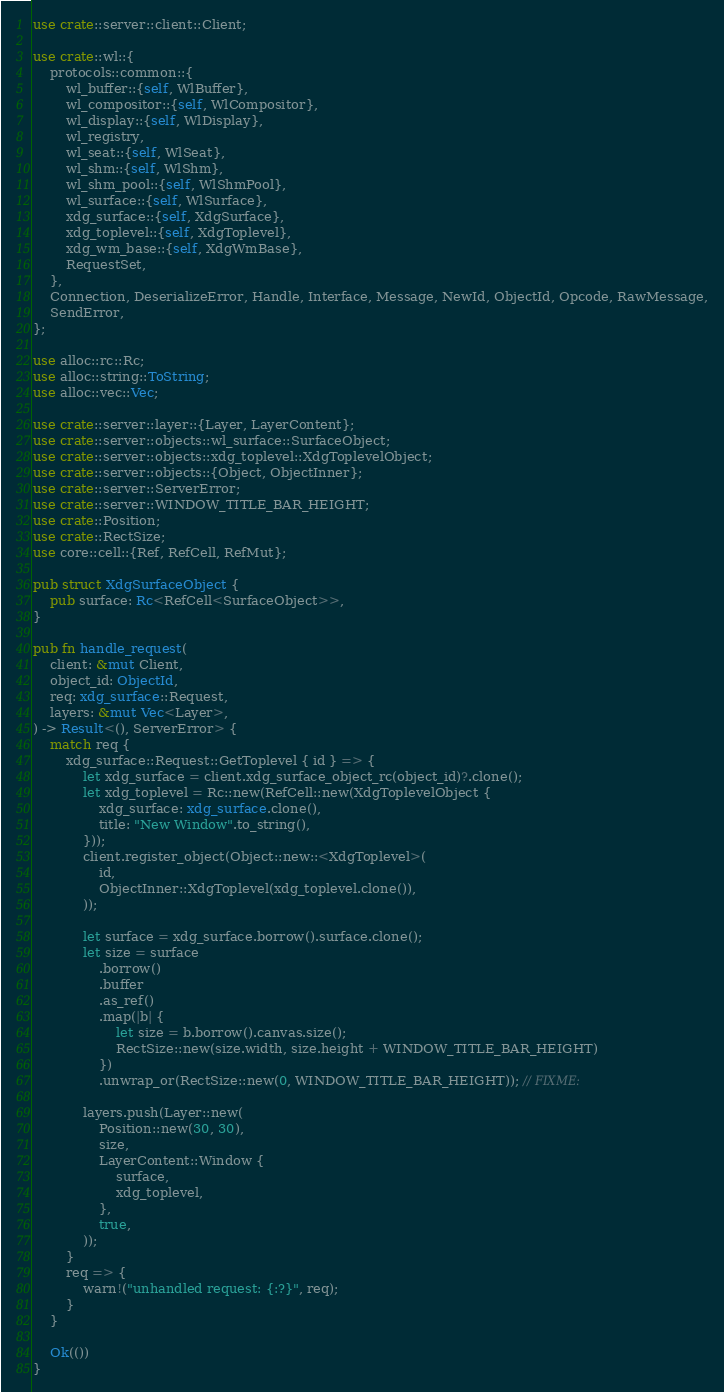<code> <loc_0><loc_0><loc_500><loc_500><_Rust_>use crate::server::client::Client;

use crate::wl::{
    protocols::common::{
        wl_buffer::{self, WlBuffer},
        wl_compositor::{self, WlCompositor},
        wl_display::{self, WlDisplay},
        wl_registry,
        wl_seat::{self, WlSeat},
        wl_shm::{self, WlShm},
        wl_shm_pool::{self, WlShmPool},
        wl_surface::{self, WlSurface},
        xdg_surface::{self, XdgSurface},
        xdg_toplevel::{self, XdgToplevel},
        xdg_wm_base::{self, XdgWmBase},
        RequestSet,
    },
    Connection, DeserializeError, Handle, Interface, Message, NewId, ObjectId, Opcode, RawMessage,
    SendError,
};

use alloc::rc::Rc;
use alloc::string::ToString;
use alloc::vec::Vec;

use crate::server::layer::{Layer, LayerContent};
use crate::server::objects::wl_surface::SurfaceObject;
use crate::server::objects::xdg_toplevel::XdgToplevelObject;
use crate::server::objects::{Object, ObjectInner};
use crate::server::ServerError;
use crate::server::WINDOW_TITLE_BAR_HEIGHT;
use crate::Position;
use crate::RectSize;
use core::cell::{Ref, RefCell, RefMut};

pub struct XdgSurfaceObject {
    pub surface: Rc<RefCell<SurfaceObject>>,
}

pub fn handle_request(
    client: &mut Client,
    object_id: ObjectId,
    req: xdg_surface::Request,
    layers: &mut Vec<Layer>,
) -> Result<(), ServerError> {
    match req {
        xdg_surface::Request::GetToplevel { id } => {
            let xdg_surface = client.xdg_surface_object_rc(object_id)?.clone();
            let xdg_toplevel = Rc::new(RefCell::new(XdgToplevelObject {
                xdg_surface: xdg_surface.clone(),
                title: "New Window".to_string(),
            }));
            client.register_object(Object::new::<XdgToplevel>(
                id,
                ObjectInner::XdgToplevel(xdg_toplevel.clone()),
            ));

            let surface = xdg_surface.borrow().surface.clone();
            let size = surface
                .borrow()
                .buffer
                .as_ref()
                .map(|b| {
                    let size = b.borrow().canvas.size();
                    RectSize::new(size.width, size.height + WINDOW_TITLE_BAR_HEIGHT)
                })
                .unwrap_or(RectSize::new(0, WINDOW_TITLE_BAR_HEIGHT)); // FIXME:

            layers.push(Layer::new(
                Position::new(30, 30),
                size,
                LayerContent::Window {
                    surface,
                    xdg_toplevel,
                },
                true,
            ));
        }
        req => {
            warn!("unhandled request: {:?}", req);
        }
    }

    Ok(())
}
</code> 